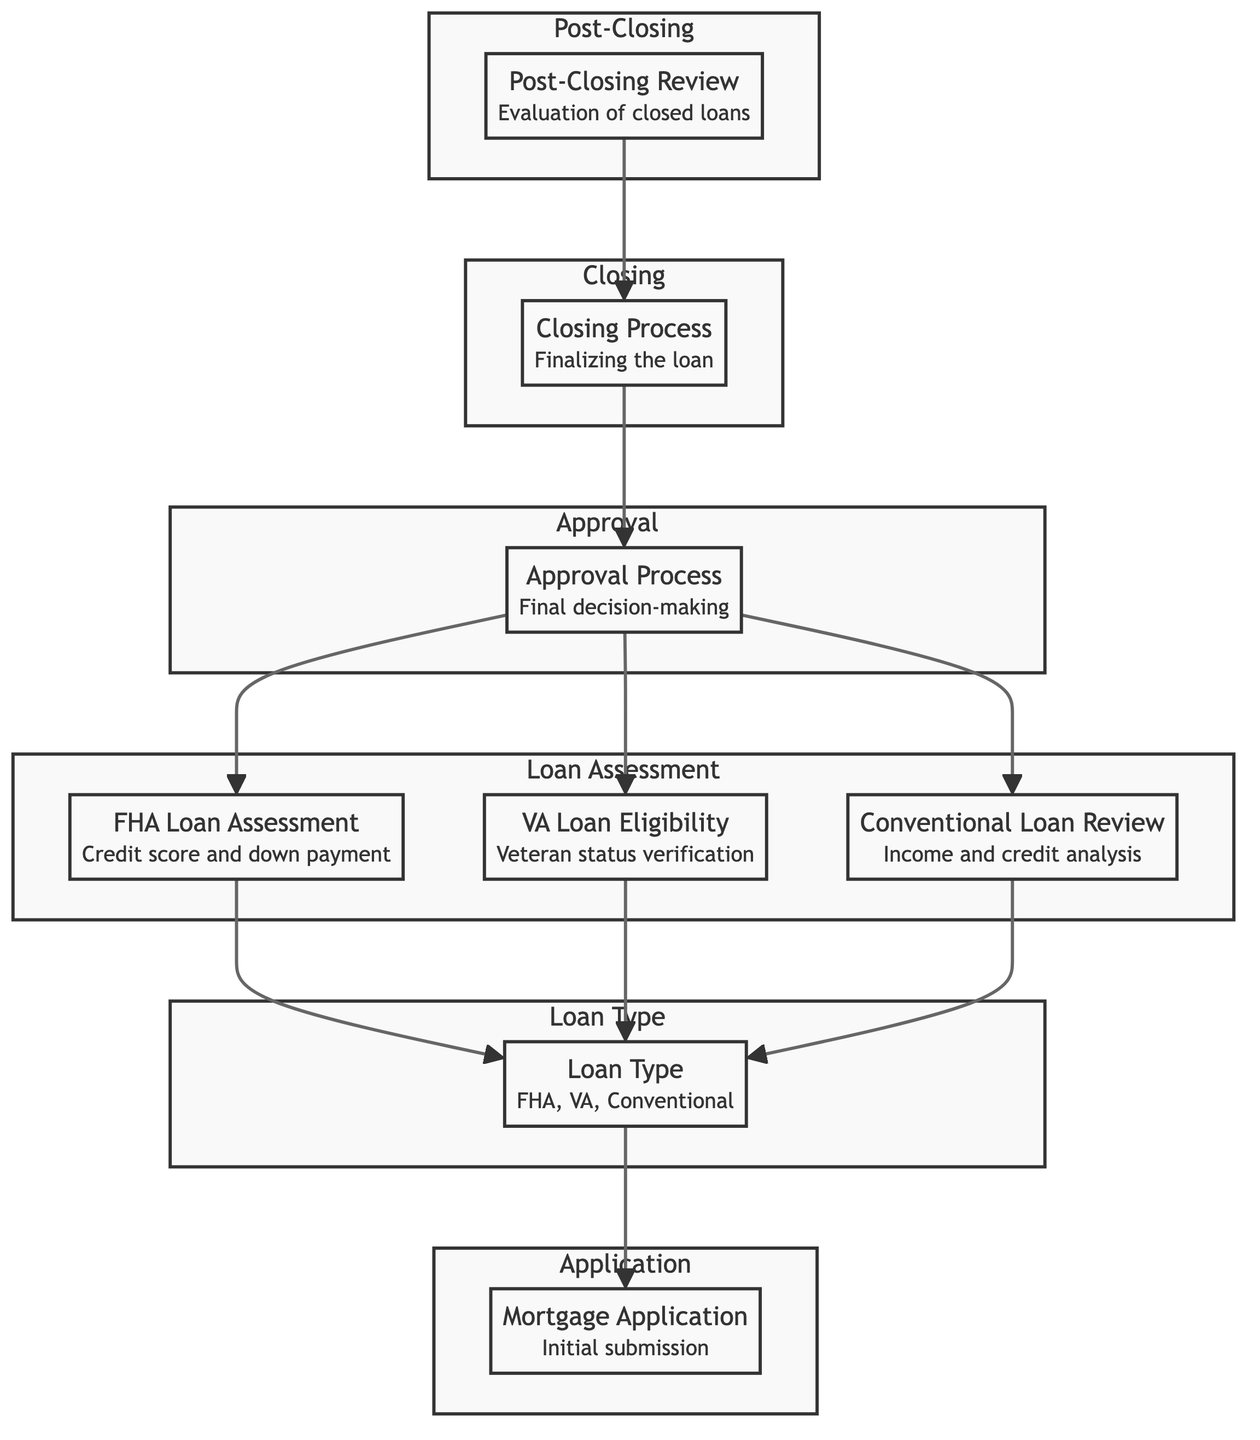What is the first step in the process? The diagram starts with the "Mortgage Application," which is the initial submission phase where borrowers provide their loan applications.
Answer: Mortgage Application How many loan types are assessed in the diagram? The diagram has a specific node labeled "Loan Type" that indicates three categories: FHA, VA, and Conventional. Counting those, there are three loan types represented.
Answer: Three What follows after the loan assessment? After the loan assessment, the "Approval Process" is the next step indicated in the flowchart that leads to finalizing the decision regarding the loan application.
Answer: Approval Process What is required for VA loan applications? The diagram specifies that "VA Loan Eligibility" involves the verification of veterans' status and entitlement for these loans, which is essential to proceed with VA loan applications.
Answer: Verification of veteran status Which process comes just before the post-closing review? The "Closing Process" is the step that directly precedes the "Post-Closing Review," as indicated by the flow of the diagram leading to the evaluation of closed loans.
Answer: Closing Process How many review processes are depicted in the flowchart? The flowchart contains two review processes: "Post-Closing Review" and "Conventional Loan Review." Each represents an evaluation of different stages in the mortgage application process.
Answer: Two What is one factor considered in the FHA loan assessment? The "FHA Loan Assessment" criteria include evaluating borrower credit scores and down payment amounts, which are vital in determining eligibility for FHA loans.
Answer: Credit score In what sequence does the application flow towards closing? The application flows from "Mortgage Application" to "Loan Type," then to the assessment stages, moving next to the "Approval Process," then the "Closing Process," and finally to "Post-Closing Review." This sequence indicates the chronological order of processing an application.
Answer: Mortgage Application → Loan Type → FHA/VA/Conventional assessments → Approval Process → Closing Process → Post-Closing Review What happens to the closed loans? After the closing process, closed loans undergo a "Post-Closing Review," which checks for compliance and overall quality control before final record-keeping.
Answer: Evaluation of closed loans 